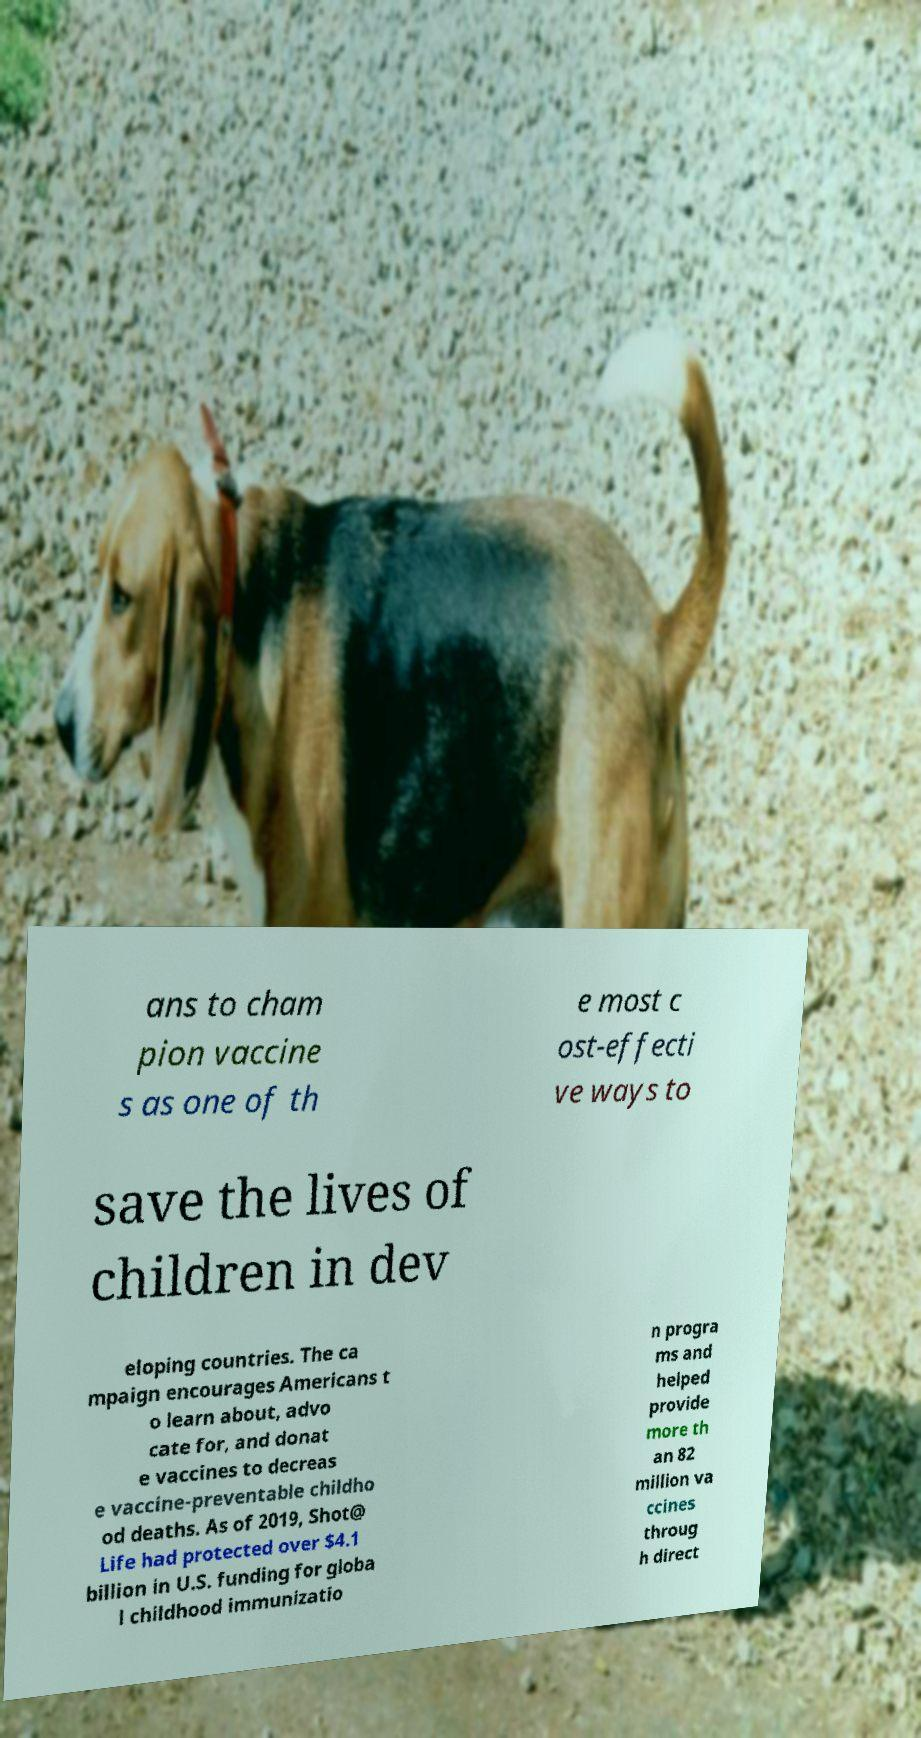Please read and relay the text visible in this image. What does it say? ans to cham pion vaccine s as one of th e most c ost-effecti ve ways to save the lives of children in dev eloping countries. The ca mpaign encourages Americans t o learn about, advo cate for, and donat e vaccines to decreas e vaccine-preventable childho od deaths. As of 2019, Shot@ Life had protected over $4.1 billion in U.S. funding for globa l childhood immunizatio n progra ms and helped provide more th an 82 million va ccines throug h direct 